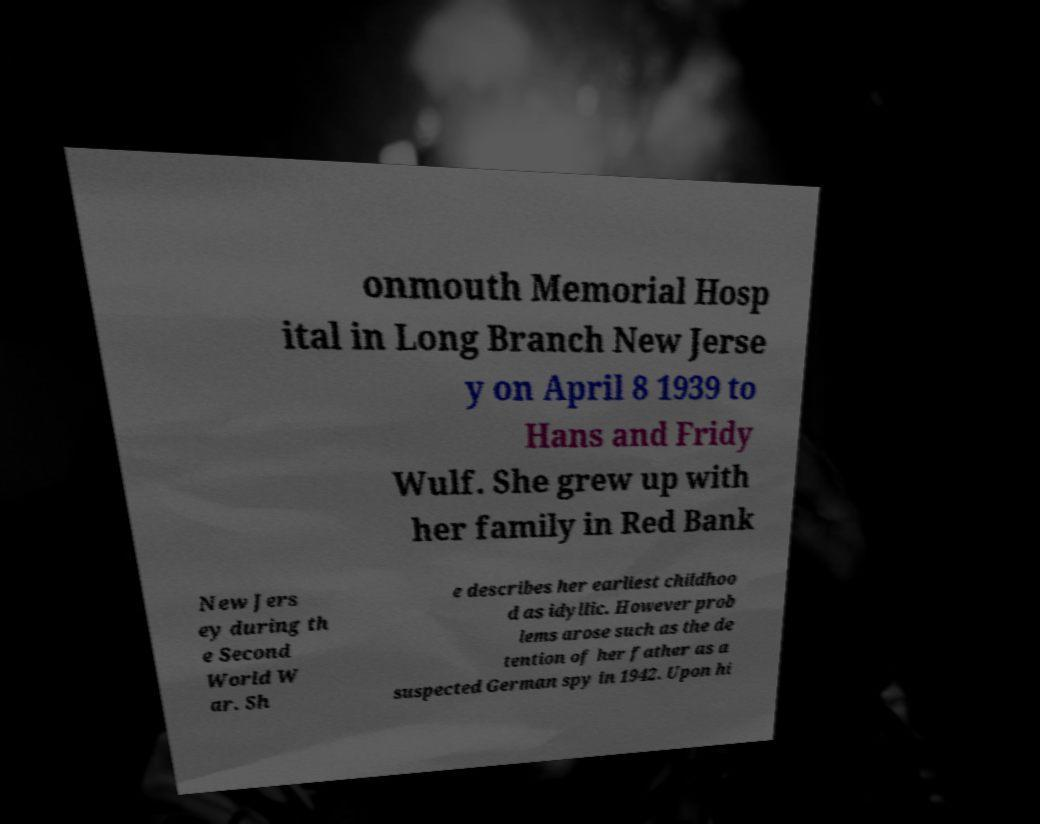There's text embedded in this image that I need extracted. Can you transcribe it verbatim? onmouth Memorial Hosp ital in Long Branch New Jerse y on April 8 1939 to Hans and Fridy Wulf. She grew up with her family in Red Bank New Jers ey during th e Second World W ar. Sh e describes her earliest childhoo d as idyllic. However prob lems arose such as the de tention of her father as a suspected German spy in 1942. Upon hi 